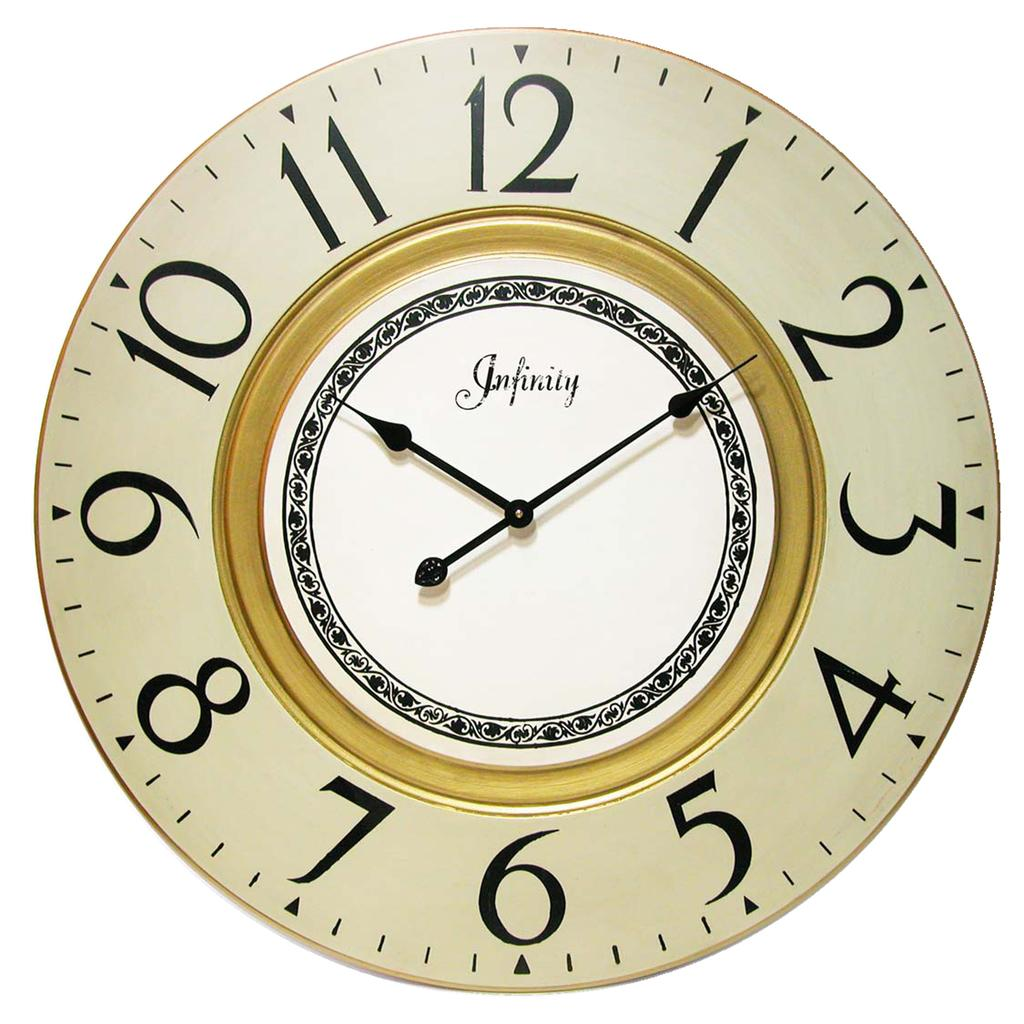<image>
Share a concise interpretation of the image provided. A large Infinity wall clock shows the time as 10:10. 